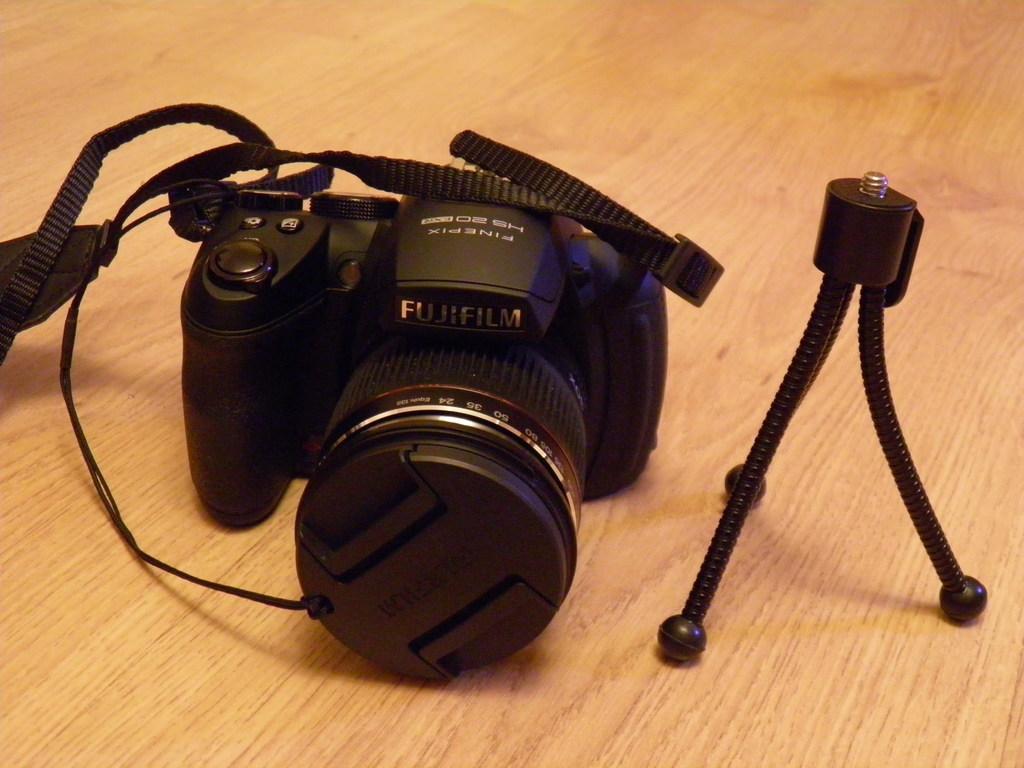Please provide a concise description of this image. In this image I can see a black colour stand on the right side and on the left side I can see a camera. 